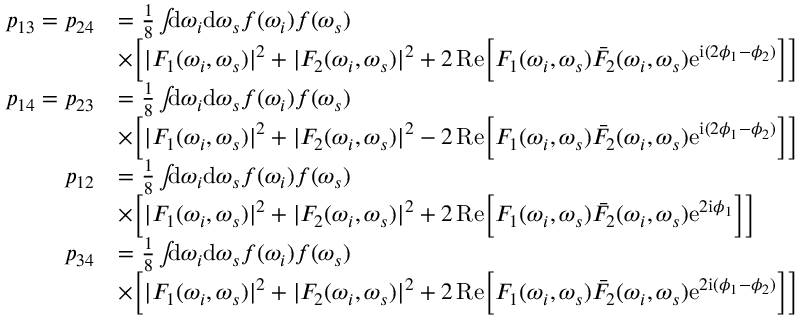<formula> <loc_0><loc_0><loc_500><loc_500>\begin{array} { r l } { p _ { 1 3 } = p _ { 2 4 } } & { = \frac { 1 } { 8 } \int \, d \omega _ { i } d \omega _ { s } f ( \omega _ { i } ) f ( \omega _ { s } ) } \\ & { \times \left [ | F _ { 1 } ( \omega _ { i } , \omega _ { s } ) | ^ { 2 } + | F _ { 2 } ( \omega _ { i } , \omega _ { s } ) | ^ { 2 } + 2 \, R e \left [ F _ { 1 } ( \omega _ { i } , \omega _ { s } ) \bar { F } _ { 2 } ( \omega _ { i } , \omega _ { s } ) e ^ { i ( 2 \phi _ { 1 } - \phi _ { 2 } ) } \right ] \right ] } \\ { p _ { 1 4 } = p _ { 2 3 } } & { = \frac { 1 } { 8 } \int \, d \omega _ { i } d \omega _ { s } f ( \omega _ { i } ) f ( \omega _ { s } ) } \\ & { \times \left [ | F _ { 1 } ( \omega _ { i } , \omega _ { s } ) | ^ { 2 } + | F _ { 2 } ( \omega _ { i } , \omega _ { s } ) | ^ { 2 } - 2 \, R e \left [ F _ { 1 } ( \omega _ { i } , \omega _ { s } ) \bar { F } _ { 2 } ( \omega _ { i } , \omega _ { s } ) e ^ { i ( 2 \phi _ { 1 } - \phi _ { 2 } ) } \right ] \right ] } \\ { p _ { 1 2 } } & { = \frac { 1 } { 8 } \int \, d \omega _ { i } d \omega _ { s } f ( \omega _ { i } ) f ( \omega _ { s } ) } \\ & { \times \left [ | F _ { 1 } ( \omega _ { i } , \omega _ { s } ) | ^ { 2 } + | F _ { 2 } ( \omega _ { i } , \omega _ { s } ) | ^ { 2 } + 2 \, R e \left [ F _ { 1 } ( \omega _ { i } , \omega _ { s } ) \bar { F } _ { 2 } ( \omega _ { i } , \omega _ { s } ) e ^ { 2 i \phi _ { 1 } } \right ] \right ] } \\ { p _ { 3 4 } } & { = \frac { 1 } { 8 } \int \, d \omega _ { i } d \omega _ { s } f ( \omega _ { i } ) f ( \omega _ { s } ) } \\ & { \times \left [ | F _ { 1 } ( \omega _ { i } , \omega _ { s } ) | ^ { 2 } + | F _ { 2 } ( \omega _ { i } , \omega _ { s } ) | ^ { 2 } + 2 \, R e \left [ F _ { 1 } ( \omega _ { i } , \omega _ { s } ) \bar { F } _ { 2 } ( \omega _ { i } , \omega _ { s } ) e ^ { 2 i ( \phi _ { 1 } - \phi _ { 2 } ) } \right ] \right ] } \end{array}</formula> 